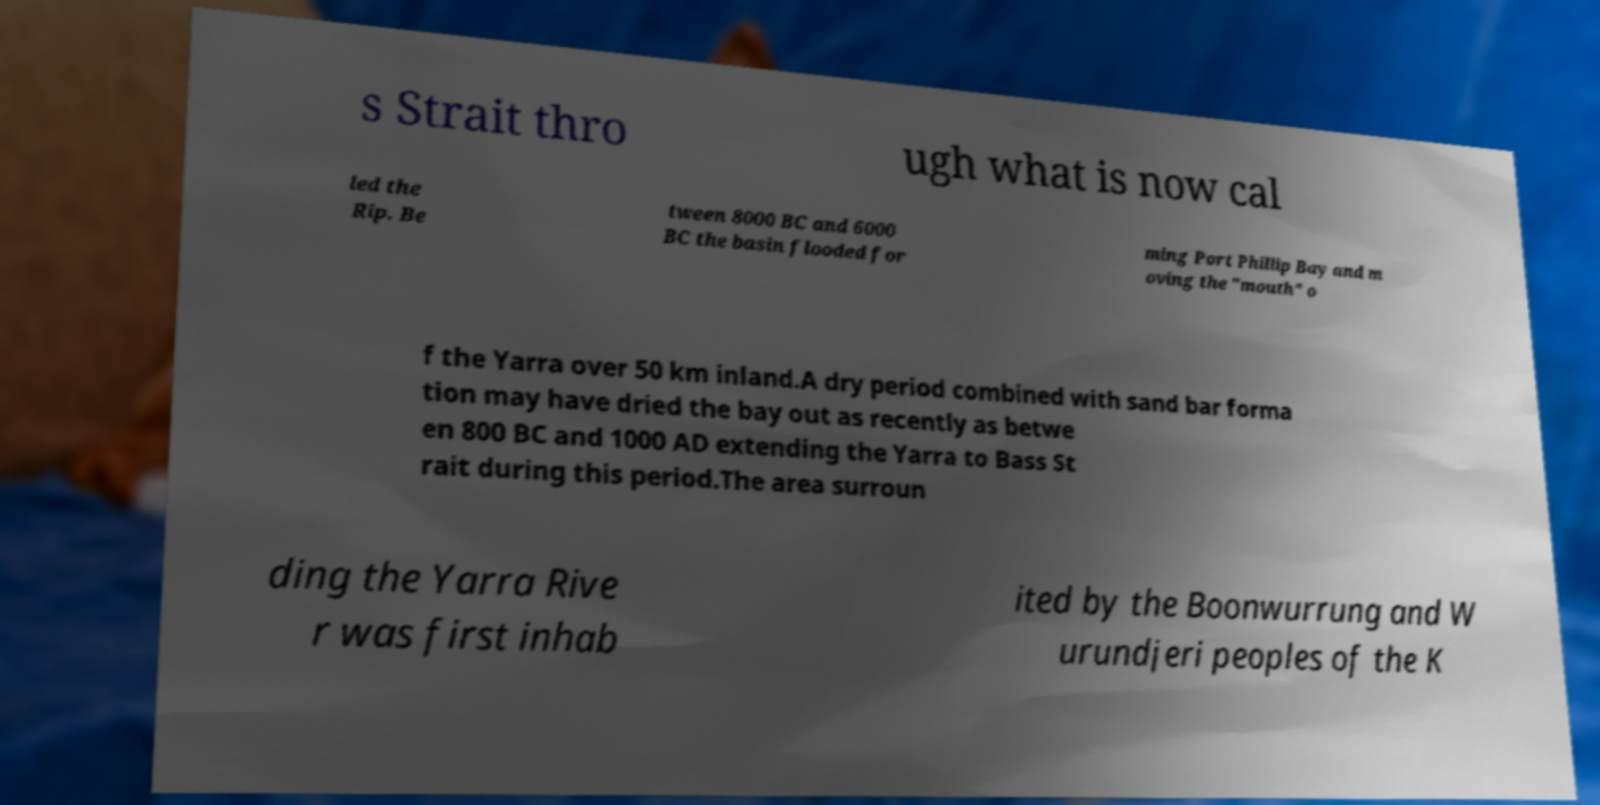Please read and relay the text visible in this image. What does it say? s Strait thro ugh what is now cal led the Rip. Be tween 8000 BC and 6000 BC the basin flooded for ming Port Phillip Bay and m oving the "mouth" o f the Yarra over 50 km inland.A dry period combined with sand bar forma tion may have dried the bay out as recently as betwe en 800 BC and 1000 AD extending the Yarra to Bass St rait during this period.The area surroun ding the Yarra Rive r was first inhab ited by the Boonwurrung and W urundjeri peoples of the K 